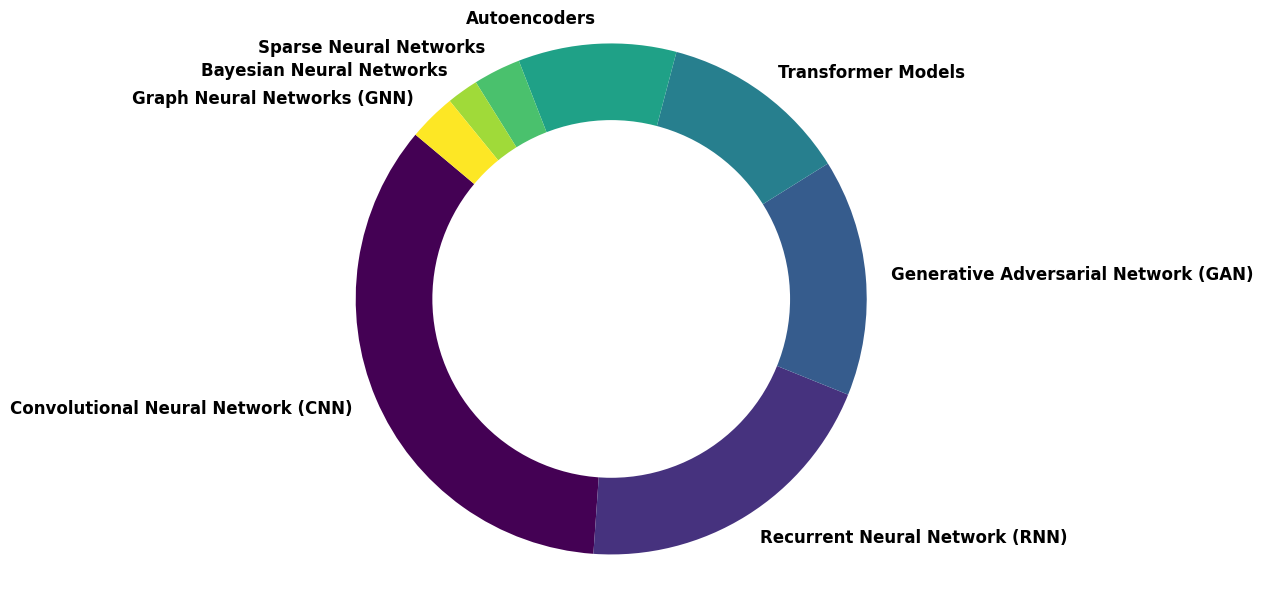Which type of neural network is the most prevalent in published deep learning research? From the pie chart, the largest segment corresponds to Convolutional Neural Networks (CNN) with a proportion of 35%.
Answer: Convolutional Neural Networks (CNN) What is the least common type of neural network according to the figure? The pie chart shows that Bayesian Neural Networks occupy the smallest segment with a proportion of 2%.
Answer: Bayesian Neural Networks What is the combined proportion of Convolutional Neural Networks (CNN) and Recurrent Neural Networks (RNN)? Convolutional Neural Networks (CNN) account for 35% and Recurrent Neural Networks (RNN) account for 20%. Summing these, 35% + 20% = 55%.
Answer: 55% How do Generative Adversarial Networks (GAN) compare to Transformer Models in terms of proportion? Generative Adversarial Networks (GAN) occupy 15% of the pie chart, while Transformer Models occupy 12%. Thus, GANs are more prevalent by 3%.
Answer: GANs are more prevalent Which two types of neural networks combined have a proportion equal to that of Convolutional Neural Networks (CNN)? Convolutional Neural Networks (CNN) have a proportion of 35%. Recurrent Neural Networks (RNN) and Autoencoders together sum to 20% + 10% = 30%; adding Sparse Neural Networks at 3% achieves 33%, which is still not enough. The combination that matches is Recurrent Neural Networks (RNN) and Generative Adversarial Networks (GAN) with 20% + 15% = 35%.
Answer: Recurrent Neural Networks (RNN) and Generative Adversarial Networks (GAN) What is the total proportion of neural networks types that have a proportion less than 10%? The charts show Bayesian Neural Networks (2%), Sparse Neural Networks (3%), Graph Neural Networks (GNN) (3%), and Autoencoders (10%). Summing those that are less than 10%: 2% + 3% + 3% = 8%.
Answer: 8% How does the proportion of Graph Neural Networks (GNN) compare to Sparse Neural Networks? Both Graph Neural Networks (GNN) and Sparse Neural Networks have a proportion of 3%.
Answer: They are equal Which type of neural network has nearly one-third the proportion of Convolutional Neural Networks (CNN)? Convolutional Neural Networks (CNN) have a proportion of 35%. One-third of this is approximately 35% / 3 ≈ 11.67%. The closest is Transformer Models at 12%.
Answer: Transformer Models What is the overall proportion of networks exceeding 10%? From the chart, networks that exceed 10% are CNN (35%), RNN (20%), GAN (15%), and Transformer Models (12%), summing these: 35% + 20% + 15% + 12% = 82%.
Answer: 82% Which neural network types fall short by 1% to create a perfect partition (sum to 100%) excluding other types? The sum of all given proportions is 100%. Since we are looking for a shortfall from perfect partitioning, each type is included in the 100%; thus, no neural network types are needed to be excluded for perfection.
Answer: No types need to be excluded 